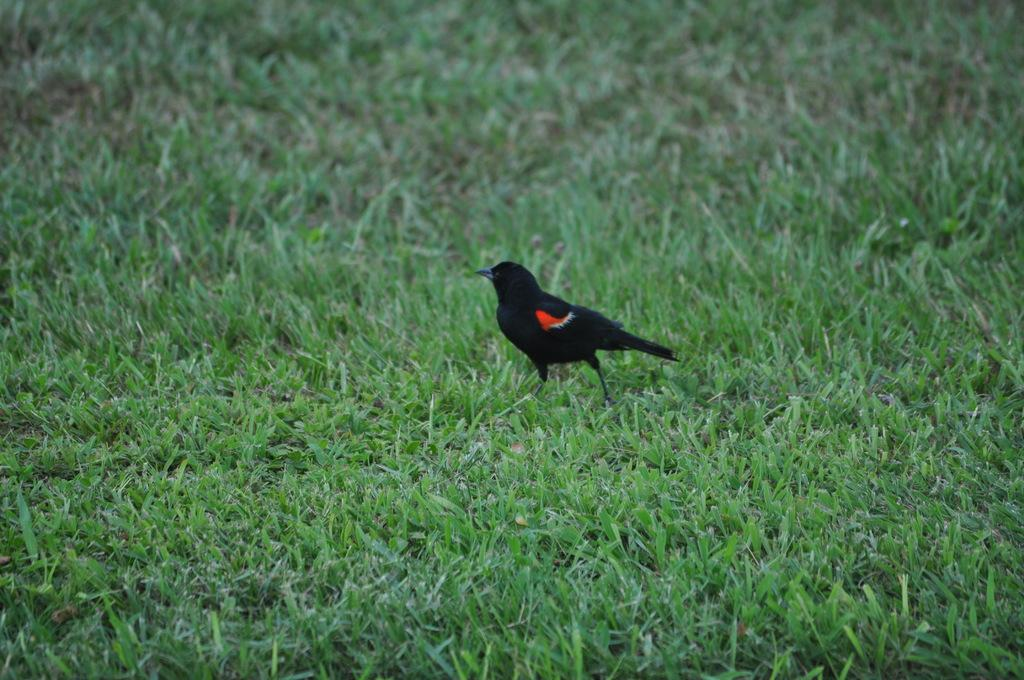What type of animal can be seen in the image? There is a bird in the image. Where is the bird located? The bird is standing on the grass. What type of desk does the bird use to write its answers in the image? There is no desk present in the image, and birds do not write answers. 